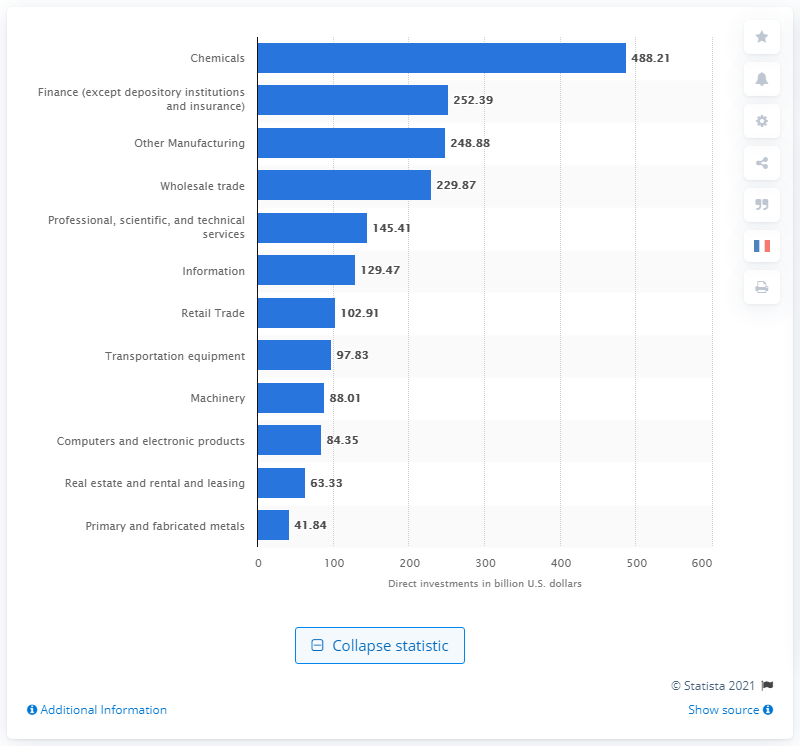Identify some key points in this picture. The European Union invested a total of $488.21 million in the chemicals industry in the United States in 2019. 